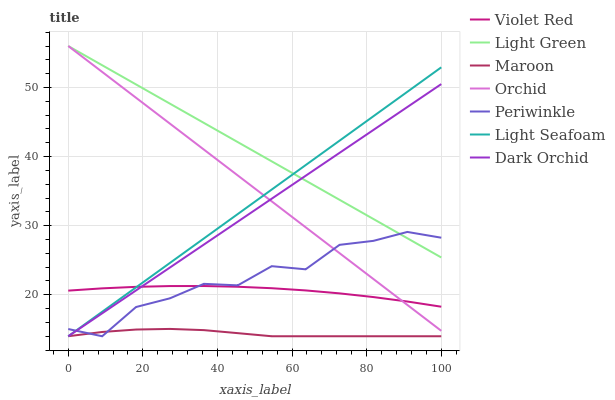Does Periwinkle have the minimum area under the curve?
Answer yes or no. No. Does Periwinkle have the maximum area under the curve?
Answer yes or no. No. Is Maroon the smoothest?
Answer yes or no. No. Is Maroon the roughest?
Answer yes or no. No. Does Light Green have the lowest value?
Answer yes or no. No. Does Periwinkle have the highest value?
Answer yes or no. No. Is Maroon less than Orchid?
Answer yes or no. Yes. Is Light Green greater than Violet Red?
Answer yes or no. Yes. Does Maroon intersect Orchid?
Answer yes or no. No. 